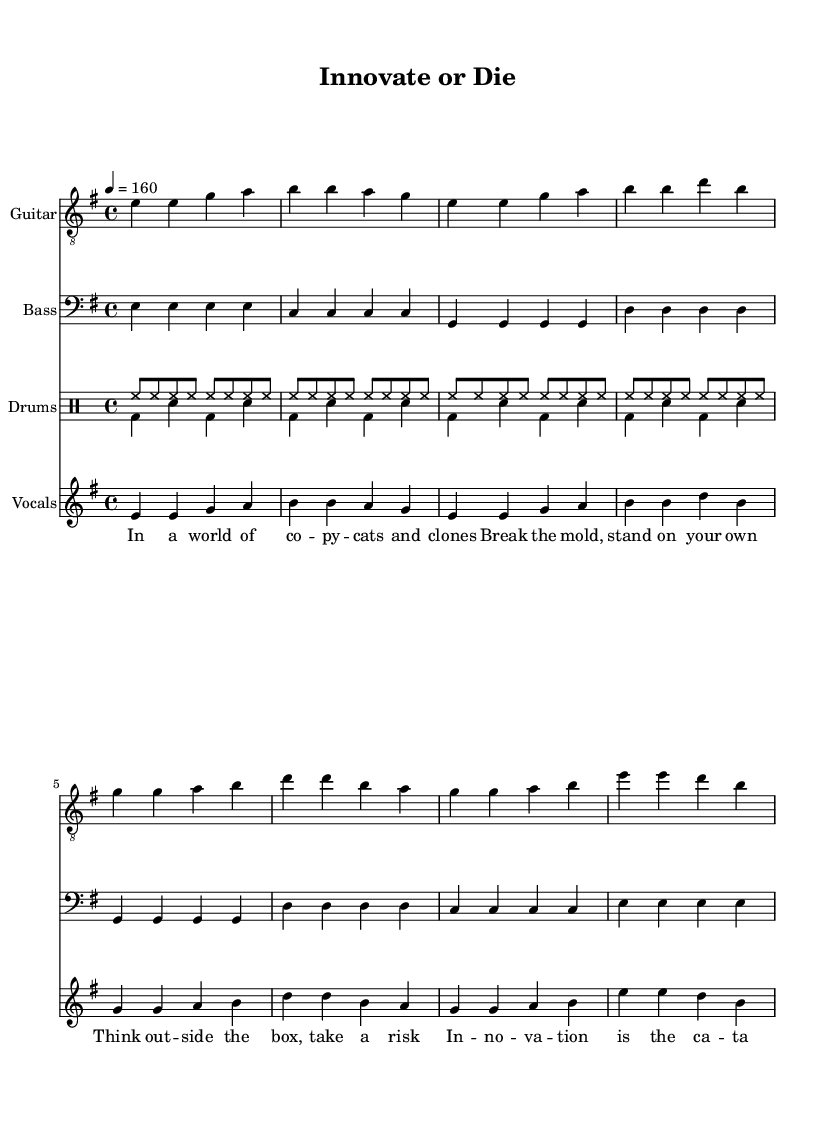What is the key signature of this music? The key signature is E minor, which has one sharp (F#). This can be deduced from the global music section where the key is defined as 'e minor'.
Answer: E minor What is the time signature of this music? The time signature is 4/4, as indicated in the global music section. It means there are four beats in each measure and a quarter note receives one beat.
Answer: 4/4 What is the tempo marking for this music? The tempo marking is '4 = 160', which indicates that there are 160 beats per minute, with the quarter note getting one beat. This tempo is listed in the global section of the sheet music.
Answer: 160 How many measures are in the chorus section? The chorus section consists of four measures, which can be counted by examining the music notation under the chorus part after identifying the transition from the verse.
Answer: 4 What is the main theme expressed in the lyrics? The main theme is centered around innovation and independent thinking, as depicted in the lyrics which emphasize breaking the mold and the entrepreneurial spirit. This can be confirmed by analyzing the content of the voiced lyrics.
Answer: Innovation Which instrument plays a repetitive high-hat pattern? The drums, specifically in the 'drumsUp' section, feature a repetitive high-hat pattern that plays consistently across the measures. This can be observed in the drum notation that highlights the high-hat placements.
Answer: Drums What do the lyrics suggest about entrepreneurship? The lyrics suggest that entrepreneurship involves taking risks and embracing unique voices, pushing against conformity. This is evident throughout the lyrics that advocate for innovation and independence in thought.
Answer: Risk-taking 